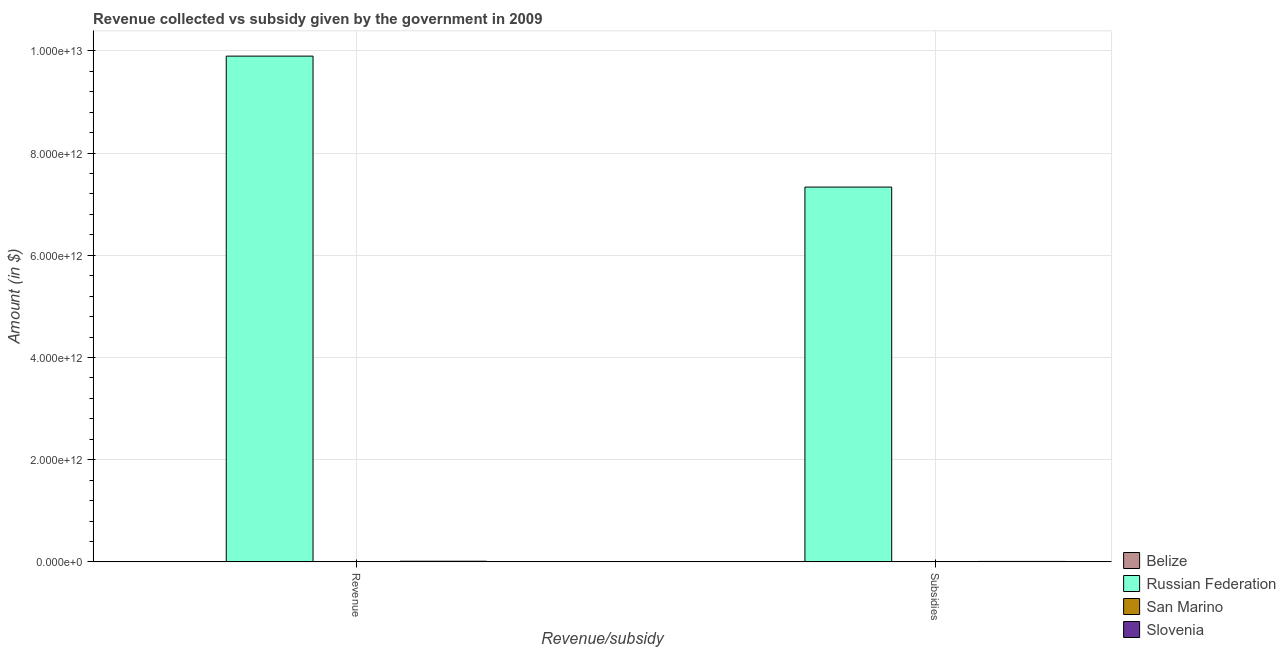How many different coloured bars are there?
Make the answer very short. 4. How many bars are there on the 1st tick from the left?
Make the answer very short. 4. What is the label of the 1st group of bars from the left?
Your answer should be compact. Revenue. What is the amount of subsidies given in San Marino?
Keep it short and to the point. 1.73e+08. Across all countries, what is the maximum amount of revenue collected?
Make the answer very short. 9.90e+12. Across all countries, what is the minimum amount of subsidies given?
Give a very brief answer. 1.41e+08. In which country was the amount of subsidies given maximum?
Give a very brief answer. Russian Federation. In which country was the amount of revenue collected minimum?
Your response must be concise. San Marino. What is the total amount of revenue collected in the graph?
Your answer should be compact. 9.91e+12. What is the difference between the amount of subsidies given in Russian Federation and that in Belize?
Offer a terse response. 7.33e+12. What is the difference between the amount of revenue collected in Russian Federation and the amount of subsidies given in San Marino?
Your answer should be compact. 9.90e+12. What is the average amount of revenue collected per country?
Give a very brief answer. 2.48e+12. What is the difference between the amount of revenue collected and amount of subsidies given in Slovenia?
Your answer should be compact. 3.84e+09. What is the ratio of the amount of revenue collected in Belize to that in Russian Federation?
Keep it short and to the point. 6.896053509002364e-5. In how many countries, is the amount of subsidies given greater than the average amount of subsidies given taken over all countries?
Give a very brief answer. 1. What does the 1st bar from the left in Subsidies represents?
Provide a short and direct response. Belize. What does the 2nd bar from the right in Subsidies represents?
Give a very brief answer. San Marino. What is the difference between two consecutive major ticks on the Y-axis?
Keep it short and to the point. 2.00e+12. Does the graph contain any zero values?
Provide a succinct answer. No. Does the graph contain grids?
Your answer should be compact. Yes. Where does the legend appear in the graph?
Keep it short and to the point. Bottom right. How are the legend labels stacked?
Offer a terse response. Vertical. What is the title of the graph?
Keep it short and to the point. Revenue collected vs subsidy given by the government in 2009. What is the label or title of the X-axis?
Give a very brief answer. Revenue/subsidy. What is the label or title of the Y-axis?
Your answer should be very brief. Amount (in $). What is the Amount (in $) of Belize in Revenue?
Provide a succinct answer. 6.83e+08. What is the Amount (in $) in Russian Federation in Revenue?
Your response must be concise. 9.90e+12. What is the Amount (in $) of San Marino in Revenue?
Provide a succinct answer. 5.62e+08. What is the Amount (in $) of Slovenia in Revenue?
Your answer should be compact. 1.31e+1. What is the Amount (in $) of Belize in Subsidies?
Make the answer very short. 1.41e+08. What is the Amount (in $) of Russian Federation in Subsidies?
Give a very brief answer. 7.33e+12. What is the Amount (in $) in San Marino in Subsidies?
Ensure brevity in your answer.  1.73e+08. What is the Amount (in $) of Slovenia in Subsidies?
Your answer should be very brief. 9.25e+09. Across all Revenue/subsidy, what is the maximum Amount (in $) in Belize?
Your answer should be compact. 6.83e+08. Across all Revenue/subsidy, what is the maximum Amount (in $) in Russian Federation?
Your answer should be very brief. 9.90e+12. Across all Revenue/subsidy, what is the maximum Amount (in $) of San Marino?
Your answer should be compact. 5.62e+08. Across all Revenue/subsidy, what is the maximum Amount (in $) in Slovenia?
Keep it short and to the point. 1.31e+1. Across all Revenue/subsidy, what is the minimum Amount (in $) of Belize?
Your answer should be very brief. 1.41e+08. Across all Revenue/subsidy, what is the minimum Amount (in $) of Russian Federation?
Give a very brief answer. 7.33e+12. Across all Revenue/subsidy, what is the minimum Amount (in $) of San Marino?
Ensure brevity in your answer.  1.73e+08. Across all Revenue/subsidy, what is the minimum Amount (in $) in Slovenia?
Offer a terse response. 9.25e+09. What is the total Amount (in $) in Belize in the graph?
Provide a short and direct response. 8.24e+08. What is the total Amount (in $) in Russian Federation in the graph?
Your answer should be very brief. 1.72e+13. What is the total Amount (in $) in San Marino in the graph?
Your answer should be compact. 7.35e+08. What is the total Amount (in $) in Slovenia in the graph?
Make the answer very short. 2.23e+1. What is the difference between the Amount (in $) of Belize in Revenue and that in Subsidies?
Offer a very short reply. 5.41e+08. What is the difference between the Amount (in $) of Russian Federation in Revenue and that in Subsidies?
Your answer should be compact. 2.56e+12. What is the difference between the Amount (in $) in San Marino in Revenue and that in Subsidies?
Make the answer very short. 3.89e+08. What is the difference between the Amount (in $) in Slovenia in Revenue and that in Subsidies?
Provide a short and direct response. 3.84e+09. What is the difference between the Amount (in $) of Belize in Revenue and the Amount (in $) of Russian Federation in Subsidies?
Make the answer very short. -7.33e+12. What is the difference between the Amount (in $) of Belize in Revenue and the Amount (in $) of San Marino in Subsidies?
Offer a very short reply. 5.10e+08. What is the difference between the Amount (in $) in Belize in Revenue and the Amount (in $) in Slovenia in Subsidies?
Your answer should be compact. -8.57e+09. What is the difference between the Amount (in $) of Russian Federation in Revenue and the Amount (in $) of San Marino in Subsidies?
Keep it short and to the point. 9.90e+12. What is the difference between the Amount (in $) in Russian Federation in Revenue and the Amount (in $) in Slovenia in Subsidies?
Your answer should be very brief. 9.89e+12. What is the difference between the Amount (in $) of San Marino in Revenue and the Amount (in $) of Slovenia in Subsidies?
Offer a very short reply. -8.69e+09. What is the average Amount (in $) in Belize per Revenue/subsidy?
Your answer should be compact. 4.12e+08. What is the average Amount (in $) in Russian Federation per Revenue/subsidy?
Offer a terse response. 8.62e+12. What is the average Amount (in $) in San Marino per Revenue/subsidy?
Your response must be concise. 3.68e+08. What is the average Amount (in $) in Slovenia per Revenue/subsidy?
Ensure brevity in your answer.  1.12e+1. What is the difference between the Amount (in $) of Belize and Amount (in $) of Russian Federation in Revenue?
Make the answer very short. -9.90e+12. What is the difference between the Amount (in $) of Belize and Amount (in $) of San Marino in Revenue?
Offer a terse response. 1.20e+08. What is the difference between the Amount (in $) in Belize and Amount (in $) in Slovenia in Revenue?
Your answer should be very brief. -1.24e+1. What is the difference between the Amount (in $) in Russian Federation and Amount (in $) in San Marino in Revenue?
Provide a succinct answer. 9.90e+12. What is the difference between the Amount (in $) of Russian Federation and Amount (in $) of Slovenia in Revenue?
Your answer should be very brief. 9.88e+12. What is the difference between the Amount (in $) in San Marino and Amount (in $) in Slovenia in Revenue?
Provide a succinct answer. -1.25e+1. What is the difference between the Amount (in $) of Belize and Amount (in $) of Russian Federation in Subsidies?
Give a very brief answer. -7.33e+12. What is the difference between the Amount (in $) in Belize and Amount (in $) in San Marino in Subsidies?
Your answer should be very brief. -3.17e+07. What is the difference between the Amount (in $) of Belize and Amount (in $) of Slovenia in Subsidies?
Make the answer very short. -9.11e+09. What is the difference between the Amount (in $) in Russian Federation and Amount (in $) in San Marino in Subsidies?
Give a very brief answer. 7.33e+12. What is the difference between the Amount (in $) in Russian Federation and Amount (in $) in Slovenia in Subsidies?
Provide a succinct answer. 7.33e+12. What is the difference between the Amount (in $) of San Marino and Amount (in $) of Slovenia in Subsidies?
Keep it short and to the point. -9.08e+09. What is the ratio of the Amount (in $) in Belize in Revenue to that in Subsidies?
Keep it short and to the point. 4.83. What is the ratio of the Amount (in $) in Russian Federation in Revenue to that in Subsidies?
Provide a short and direct response. 1.35. What is the ratio of the Amount (in $) of San Marino in Revenue to that in Subsidies?
Offer a terse response. 3.25. What is the ratio of the Amount (in $) of Slovenia in Revenue to that in Subsidies?
Provide a short and direct response. 1.41. What is the difference between the highest and the second highest Amount (in $) in Belize?
Your answer should be very brief. 5.41e+08. What is the difference between the highest and the second highest Amount (in $) in Russian Federation?
Make the answer very short. 2.56e+12. What is the difference between the highest and the second highest Amount (in $) of San Marino?
Your response must be concise. 3.89e+08. What is the difference between the highest and the second highest Amount (in $) of Slovenia?
Make the answer very short. 3.84e+09. What is the difference between the highest and the lowest Amount (in $) in Belize?
Give a very brief answer. 5.41e+08. What is the difference between the highest and the lowest Amount (in $) of Russian Federation?
Your answer should be compact. 2.56e+12. What is the difference between the highest and the lowest Amount (in $) of San Marino?
Provide a succinct answer. 3.89e+08. What is the difference between the highest and the lowest Amount (in $) in Slovenia?
Give a very brief answer. 3.84e+09. 